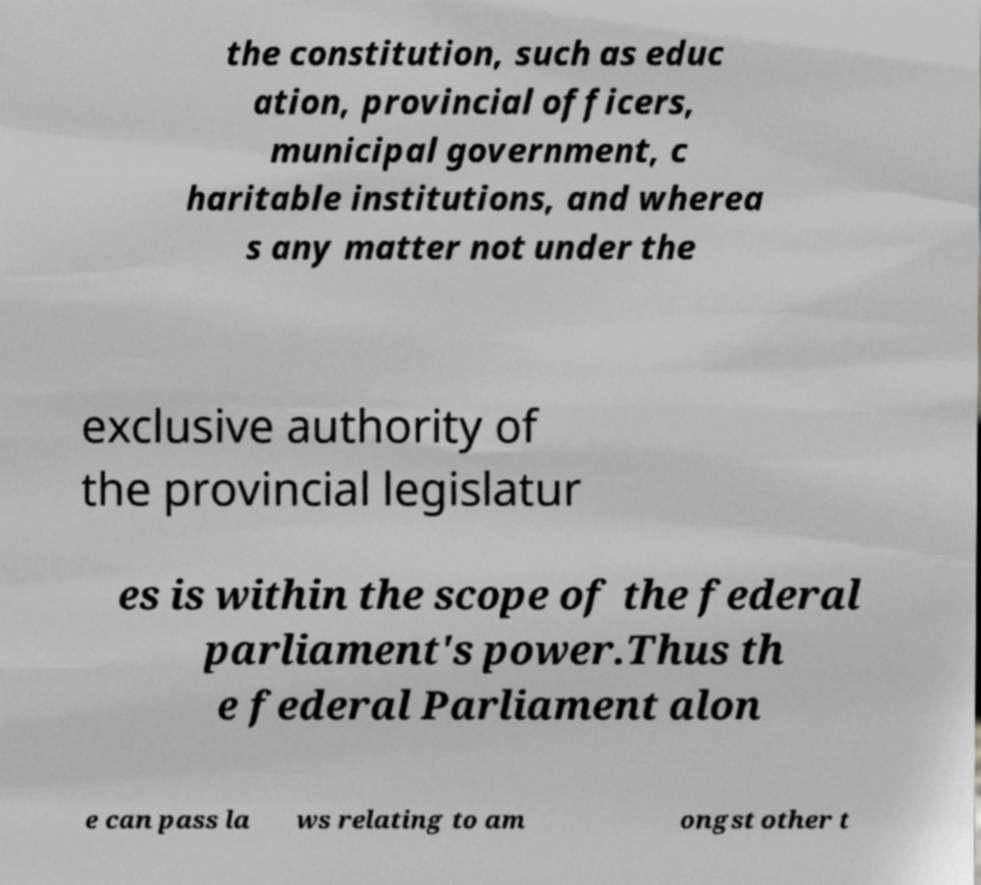There's text embedded in this image that I need extracted. Can you transcribe it verbatim? the constitution, such as educ ation, provincial officers, municipal government, c haritable institutions, and wherea s any matter not under the exclusive authority of the provincial legislatur es is within the scope of the federal parliament's power.Thus th e federal Parliament alon e can pass la ws relating to am ongst other t 